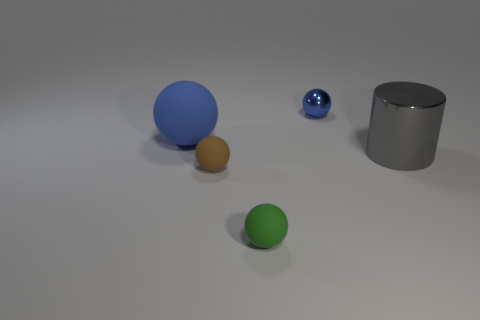Can you describe the lighting and shadows present in the scene? The image features soft, diffused lighting that casts gentle shadows to the right of the objects. This lighting creates a calm and even tone across the scene. 